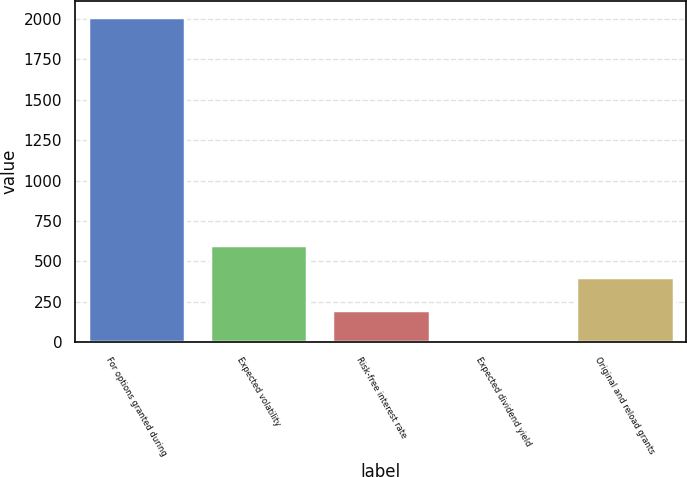Convert chart. <chart><loc_0><loc_0><loc_500><loc_500><bar_chart><fcel>For options granted during<fcel>Expected volatility<fcel>Risk-free interest rate<fcel>Expected dividend yield<fcel>Original and reload grants<nl><fcel>2009<fcel>602.72<fcel>200.92<fcel>0.02<fcel>401.82<nl></chart> 